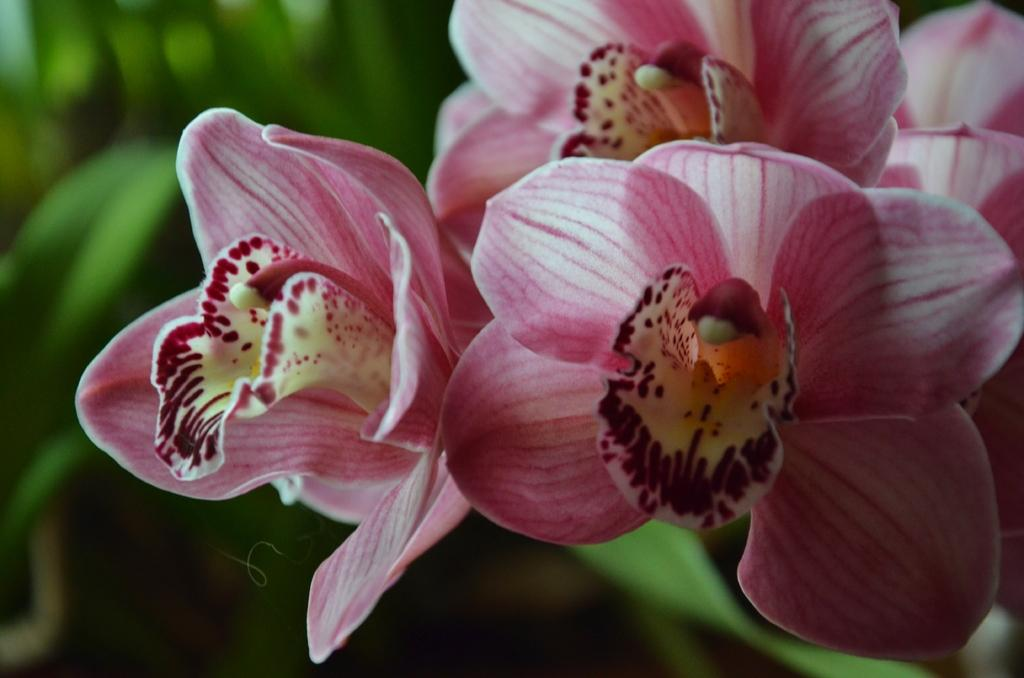What type of plants can be seen in the image? There are flowers in the image. Can you describe the background of the image? The background of the image is green and blurred. What type of coal is being used in the class depicted in the image? There is no coal or class present in the image; it features flowers and a green, blurred background. 